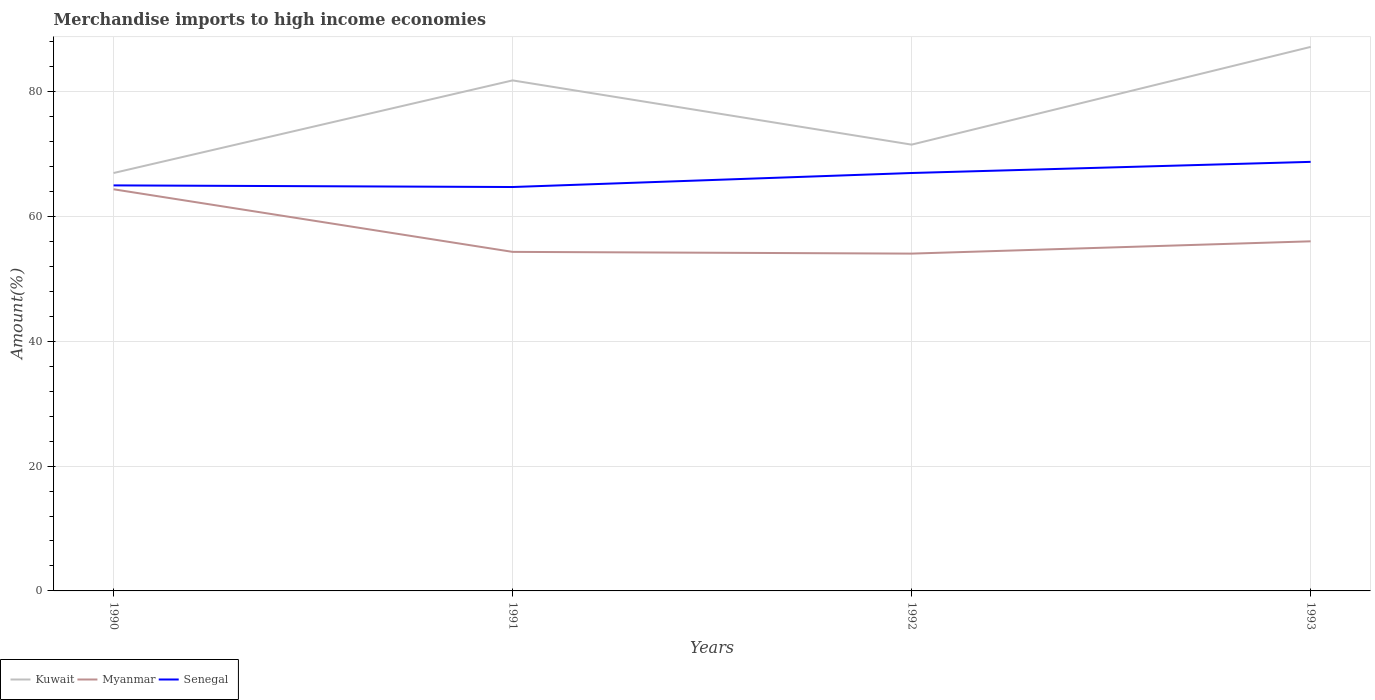Does the line corresponding to Myanmar intersect with the line corresponding to Senegal?
Make the answer very short. No. Is the number of lines equal to the number of legend labels?
Your answer should be compact. Yes. Across all years, what is the maximum percentage of amount earned from merchandise imports in Senegal?
Offer a terse response. 64.71. What is the total percentage of amount earned from merchandise imports in Kuwait in the graph?
Your answer should be very brief. -20.2. What is the difference between the highest and the second highest percentage of amount earned from merchandise imports in Kuwait?
Provide a succinct answer. 20.2. Is the percentage of amount earned from merchandise imports in Senegal strictly greater than the percentage of amount earned from merchandise imports in Kuwait over the years?
Your answer should be very brief. Yes. How many lines are there?
Your answer should be very brief. 3. How many years are there in the graph?
Make the answer very short. 4. Does the graph contain any zero values?
Offer a very short reply. No. Does the graph contain grids?
Your response must be concise. Yes. How many legend labels are there?
Your answer should be compact. 3. What is the title of the graph?
Offer a terse response. Merchandise imports to high income economies. Does "Morocco" appear as one of the legend labels in the graph?
Offer a very short reply. No. What is the label or title of the X-axis?
Offer a very short reply. Years. What is the label or title of the Y-axis?
Ensure brevity in your answer.  Amount(%). What is the Amount(%) of Kuwait in 1990?
Your answer should be compact. 66.95. What is the Amount(%) of Myanmar in 1990?
Provide a succinct answer. 64.35. What is the Amount(%) in Senegal in 1990?
Make the answer very short. 64.97. What is the Amount(%) of Kuwait in 1991?
Provide a short and direct response. 81.79. What is the Amount(%) of Myanmar in 1991?
Provide a succinct answer. 54.32. What is the Amount(%) of Senegal in 1991?
Make the answer very short. 64.71. What is the Amount(%) of Kuwait in 1992?
Your answer should be compact. 71.5. What is the Amount(%) in Myanmar in 1992?
Provide a succinct answer. 54.04. What is the Amount(%) of Senegal in 1992?
Make the answer very short. 66.96. What is the Amount(%) in Kuwait in 1993?
Give a very brief answer. 87.16. What is the Amount(%) of Myanmar in 1993?
Ensure brevity in your answer.  56.01. What is the Amount(%) in Senegal in 1993?
Provide a succinct answer. 68.74. Across all years, what is the maximum Amount(%) of Kuwait?
Your response must be concise. 87.16. Across all years, what is the maximum Amount(%) of Myanmar?
Your answer should be very brief. 64.35. Across all years, what is the maximum Amount(%) of Senegal?
Your answer should be compact. 68.74. Across all years, what is the minimum Amount(%) of Kuwait?
Your answer should be very brief. 66.95. Across all years, what is the minimum Amount(%) of Myanmar?
Offer a terse response. 54.04. Across all years, what is the minimum Amount(%) of Senegal?
Keep it short and to the point. 64.71. What is the total Amount(%) of Kuwait in the graph?
Ensure brevity in your answer.  307.41. What is the total Amount(%) in Myanmar in the graph?
Provide a short and direct response. 228.73. What is the total Amount(%) of Senegal in the graph?
Your answer should be very brief. 265.38. What is the difference between the Amount(%) in Kuwait in 1990 and that in 1991?
Offer a terse response. -14.84. What is the difference between the Amount(%) in Myanmar in 1990 and that in 1991?
Ensure brevity in your answer.  10.03. What is the difference between the Amount(%) in Senegal in 1990 and that in 1991?
Provide a short and direct response. 0.26. What is the difference between the Amount(%) in Kuwait in 1990 and that in 1992?
Ensure brevity in your answer.  -4.55. What is the difference between the Amount(%) of Myanmar in 1990 and that in 1992?
Your answer should be compact. 10.31. What is the difference between the Amount(%) of Senegal in 1990 and that in 1992?
Your answer should be compact. -1.98. What is the difference between the Amount(%) in Kuwait in 1990 and that in 1993?
Offer a very short reply. -20.2. What is the difference between the Amount(%) of Myanmar in 1990 and that in 1993?
Give a very brief answer. 8.34. What is the difference between the Amount(%) in Senegal in 1990 and that in 1993?
Offer a very short reply. -3.77. What is the difference between the Amount(%) in Kuwait in 1991 and that in 1992?
Your response must be concise. 10.29. What is the difference between the Amount(%) in Myanmar in 1991 and that in 1992?
Make the answer very short. 0.28. What is the difference between the Amount(%) in Senegal in 1991 and that in 1992?
Keep it short and to the point. -2.24. What is the difference between the Amount(%) in Kuwait in 1991 and that in 1993?
Make the answer very short. -5.37. What is the difference between the Amount(%) in Myanmar in 1991 and that in 1993?
Provide a short and direct response. -1.69. What is the difference between the Amount(%) of Senegal in 1991 and that in 1993?
Your answer should be compact. -4.03. What is the difference between the Amount(%) in Kuwait in 1992 and that in 1993?
Make the answer very short. -15.66. What is the difference between the Amount(%) in Myanmar in 1992 and that in 1993?
Make the answer very short. -1.97. What is the difference between the Amount(%) in Senegal in 1992 and that in 1993?
Offer a very short reply. -1.79. What is the difference between the Amount(%) of Kuwait in 1990 and the Amount(%) of Myanmar in 1991?
Your answer should be very brief. 12.63. What is the difference between the Amount(%) of Kuwait in 1990 and the Amount(%) of Senegal in 1991?
Ensure brevity in your answer.  2.24. What is the difference between the Amount(%) in Myanmar in 1990 and the Amount(%) in Senegal in 1991?
Your answer should be very brief. -0.36. What is the difference between the Amount(%) in Kuwait in 1990 and the Amount(%) in Myanmar in 1992?
Offer a very short reply. 12.91. What is the difference between the Amount(%) of Kuwait in 1990 and the Amount(%) of Senegal in 1992?
Your response must be concise. -0. What is the difference between the Amount(%) of Myanmar in 1990 and the Amount(%) of Senegal in 1992?
Offer a terse response. -2.61. What is the difference between the Amount(%) of Kuwait in 1990 and the Amount(%) of Myanmar in 1993?
Keep it short and to the point. 10.94. What is the difference between the Amount(%) of Kuwait in 1990 and the Amount(%) of Senegal in 1993?
Your response must be concise. -1.79. What is the difference between the Amount(%) of Myanmar in 1990 and the Amount(%) of Senegal in 1993?
Provide a succinct answer. -4.39. What is the difference between the Amount(%) of Kuwait in 1991 and the Amount(%) of Myanmar in 1992?
Give a very brief answer. 27.75. What is the difference between the Amount(%) in Kuwait in 1991 and the Amount(%) in Senegal in 1992?
Offer a very short reply. 14.84. What is the difference between the Amount(%) of Myanmar in 1991 and the Amount(%) of Senegal in 1992?
Keep it short and to the point. -12.64. What is the difference between the Amount(%) of Kuwait in 1991 and the Amount(%) of Myanmar in 1993?
Your answer should be very brief. 25.78. What is the difference between the Amount(%) in Kuwait in 1991 and the Amount(%) in Senegal in 1993?
Give a very brief answer. 13.05. What is the difference between the Amount(%) in Myanmar in 1991 and the Amount(%) in Senegal in 1993?
Your answer should be very brief. -14.42. What is the difference between the Amount(%) of Kuwait in 1992 and the Amount(%) of Myanmar in 1993?
Offer a terse response. 15.49. What is the difference between the Amount(%) in Kuwait in 1992 and the Amount(%) in Senegal in 1993?
Your answer should be compact. 2.76. What is the difference between the Amount(%) in Myanmar in 1992 and the Amount(%) in Senegal in 1993?
Offer a terse response. -14.7. What is the average Amount(%) in Kuwait per year?
Your answer should be compact. 76.85. What is the average Amount(%) in Myanmar per year?
Offer a terse response. 57.18. What is the average Amount(%) of Senegal per year?
Keep it short and to the point. 66.35. In the year 1990, what is the difference between the Amount(%) of Kuwait and Amount(%) of Myanmar?
Your response must be concise. 2.6. In the year 1990, what is the difference between the Amount(%) in Kuwait and Amount(%) in Senegal?
Make the answer very short. 1.98. In the year 1990, what is the difference between the Amount(%) in Myanmar and Amount(%) in Senegal?
Your answer should be compact. -0.62. In the year 1991, what is the difference between the Amount(%) in Kuwait and Amount(%) in Myanmar?
Your answer should be compact. 27.47. In the year 1991, what is the difference between the Amount(%) of Kuwait and Amount(%) of Senegal?
Make the answer very short. 17.08. In the year 1991, what is the difference between the Amount(%) in Myanmar and Amount(%) in Senegal?
Provide a short and direct response. -10.39. In the year 1992, what is the difference between the Amount(%) in Kuwait and Amount(%) in Myanmar?
Give a very brief answer. 17.46. In the year 1992, what is the difference between the Amount(%) of Kuwait and Amount(%) of Senegal?
Your answer should be compact. 4.55. In the year 1992, what is the difference between the Amount(%) in Myanmar and Amount(%) in Senegal?
Your answer should be compact. -12.91. In the year 1993, what is the difference between the Amount(%) in Kuwait and Amount(%) in Myanmar?
Offer a terse response. 31.15. In the year 1993, what is the difference between the Amount(%) in Kuwait and Amount(%) in Senegal?
Provide a succinct answer. 18.42. In the year 1993, what is the difference between the Amount(%) of Myanmar and Amount(%) of Senegal?
Your answer should be very brief. -12.73. What is the ratio of the Amount(%) of Kuwait in 1990 to that in 1991?
Offer a very short reply. 0.82. What is the ratio of the Amount(%) in Myanmar in 1990 to that in 1991?
Your response must be concise. 1.18. What is the ratio of the Amount(%) of Kuwait in 1990 to that in 1992?
Ensure brevity in your answer.  0.94. What is the ratio of the Amount(%) of Myanmar in 1990 to that in 1992?
Your answer should be compact. 1.19. What is the ratio of the Amount(%) of Senegal in 1990 to that in 1992?
Your answer should be very brief. 0.97. What is the ratio of the Amount(%) of Kuwait in 1990 to that in 1993?
Make the answer very short. 0.77. What is the ratio of the Amount(%) in Myanmar in 1990 to that in 1993?
Offer a very short reply. 1.15. What is the ratio of the Amount(%) in Senegal in 1990 to that in 1993?
Your answer should be very brief. 0.95. What is the ratio of the Amount(%) of Kuwait in 1991 to that in 1992?
Provide a short and direct response. 1.14. What is the ratio of the Amount(%) in Myanmar in 1991 to that in 1992?
Your response must be concise. 1.01. What is the ratio of the Amount(%) of Senegal in 1991 to that in 1992?
Offer a very short reply. 0.97. What is the ratio of the Amount(%) in Kuwait in 1991 to that in 1993?
Provide a succinct answer. 0.94. What is the ratio of the Amount(%) in Myanmar in 1991 to that in 1993?
Your answer should be compact. 0.97. What is the ratio of the Amount(%) of Senegal in 1991 to that in 1993?
Offer a very short reply. 0.94. What is the ratio of the Amount(%) of Kuwait in 1992 to that in 1993?
Make the answer very short. 0.82. What is the ratio of the Amount(%) in Myanmar in 1992 to that in 1993?
Offer a very short reply. 0.96. What is the ratio of the Amount(%) of Senegal in 1992 to that in 1993?
Offer a very short reply. 0.97. What is the difference between the highest and the second highest Amount(%) of Kuwait?
Ensure brevity in your answer.  5.37. What is the difference between the highest and the second highest Amount(%) in Myanmar?
Keep it short and to the point. 8.34. What is the difference between the highest and the second highest Amount(%) in Senegal?
Offer a very short reply. 1.79. What is the difference between the highest and the lowest Amount(%) of Kuwait?
Your answer should be compact. 20.2. What is the difference between the highest and the lowest Amount(%) of Myanmar?
Provide a succinct answer. 10.31. What is the difference between the highest and the lowest Amount(%) of Senegal?
Your response must be concise. 4.03. 